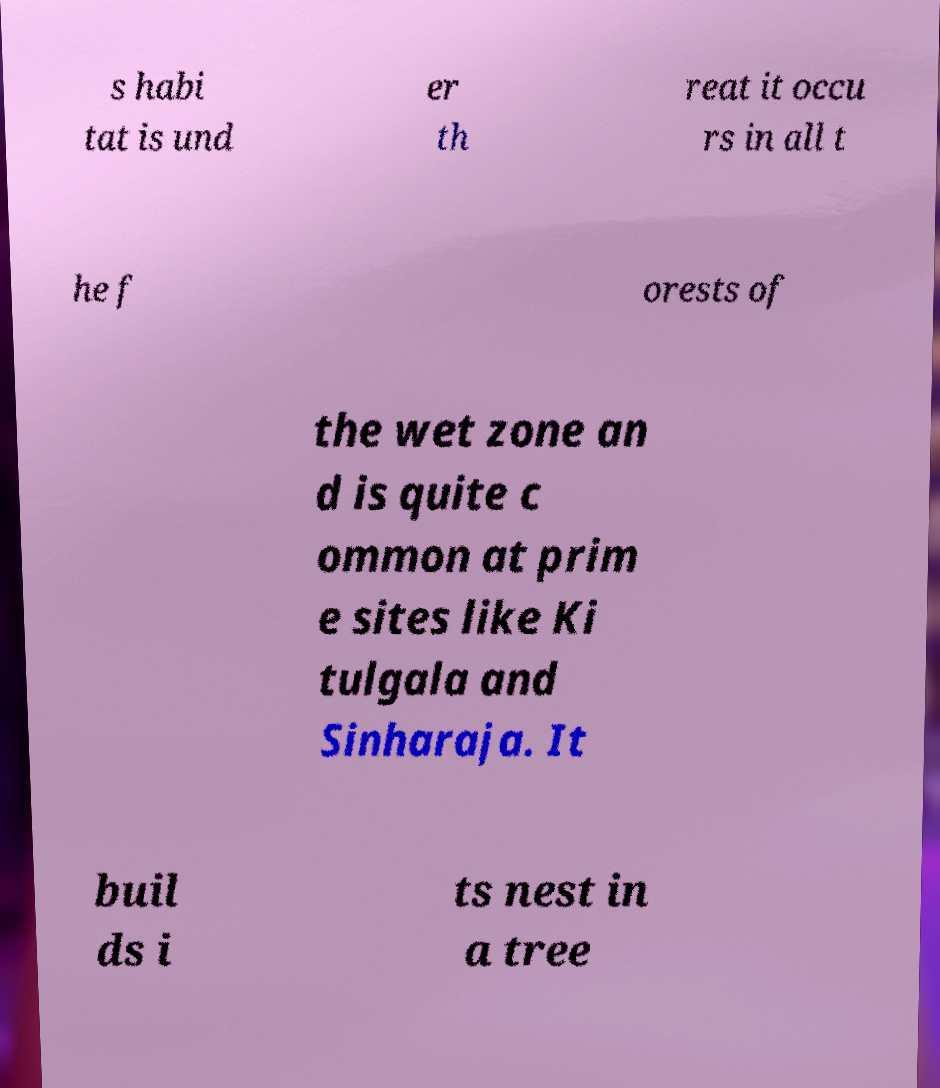Could you assist in decoding the text presented in this image and type it out clearly? s habi tat is und er th reat it occu rs in all t he f orests of the wet zone an d is quite c ommon at prim e sites like Ki tulgala and Sinharaja. It buil ds i ts nest in a tree 